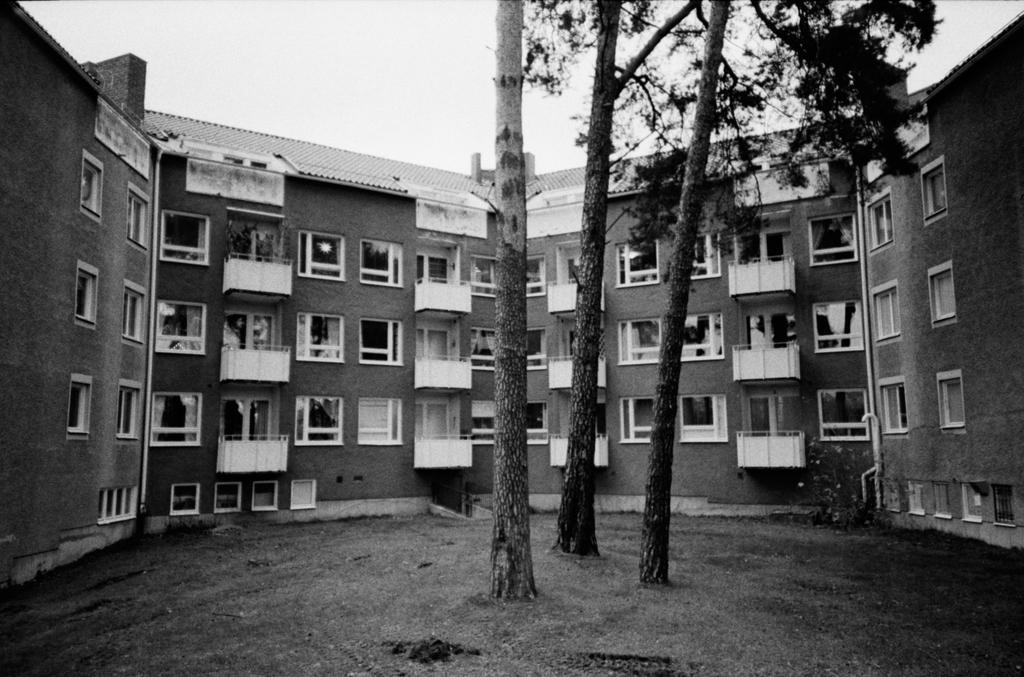Describe this image in one or two sentences. In this image in the middle there are three trees. In the background there is a tree. 